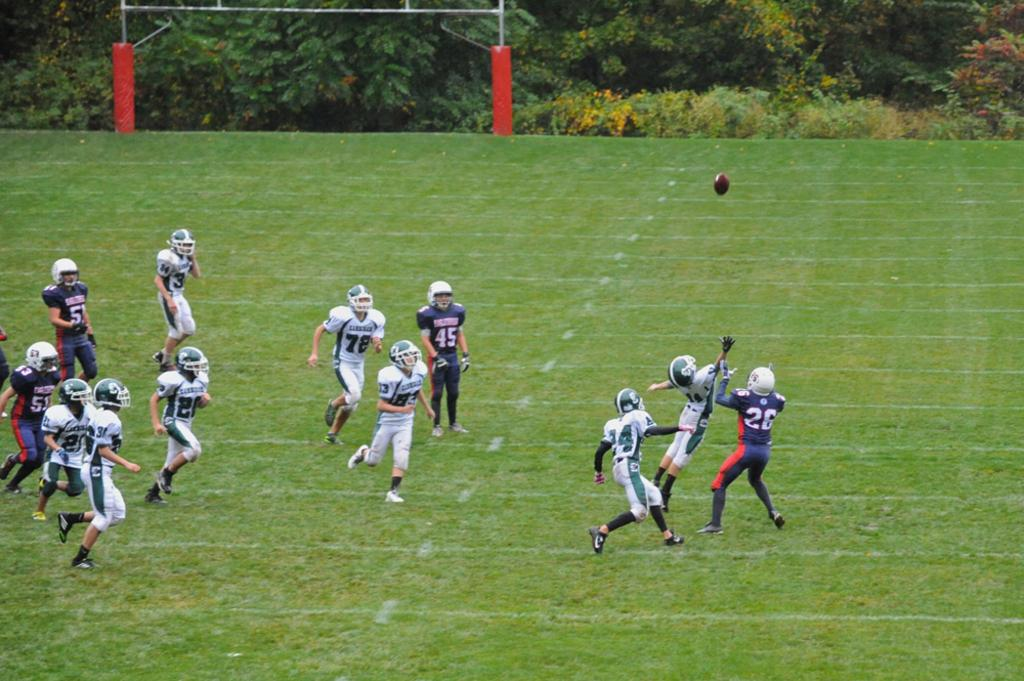Who or what is present in the image? There are people in the image. Where are the people located in the image? The people are in the center of the image. What type of environment are the people in? The people are on a grassland. What are the people doing in the image? The people are playing. What object can be seen in the image related to the game? There is a net in the image. What can be seen at the top side of the image? There are plants at the top side of the image. What type of steel structure can be seen in the image? There is no steel structure present in the image; it features people playing on a grassland with a net. 